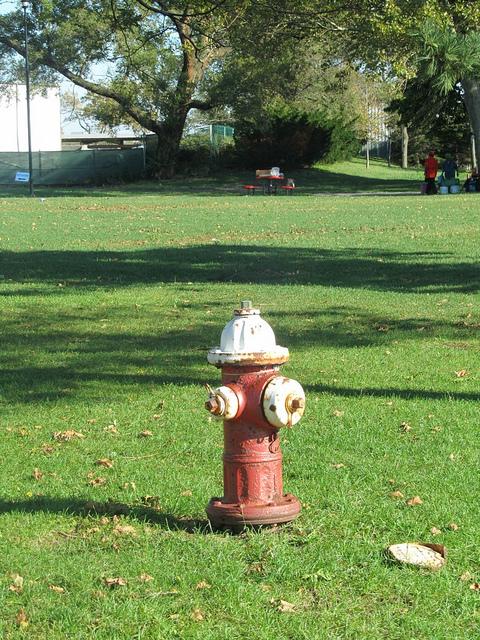Is this a park area?
Write a very short answer. Yes. Is the fire hydrant by the road?
Be succinct. No. Should they mow their lawn?
Answer briefly. No. What is the sex of the person behind the fire hydrant?
Keep it brief. Male. Is this a park?
Write a very short answer. Yes. 